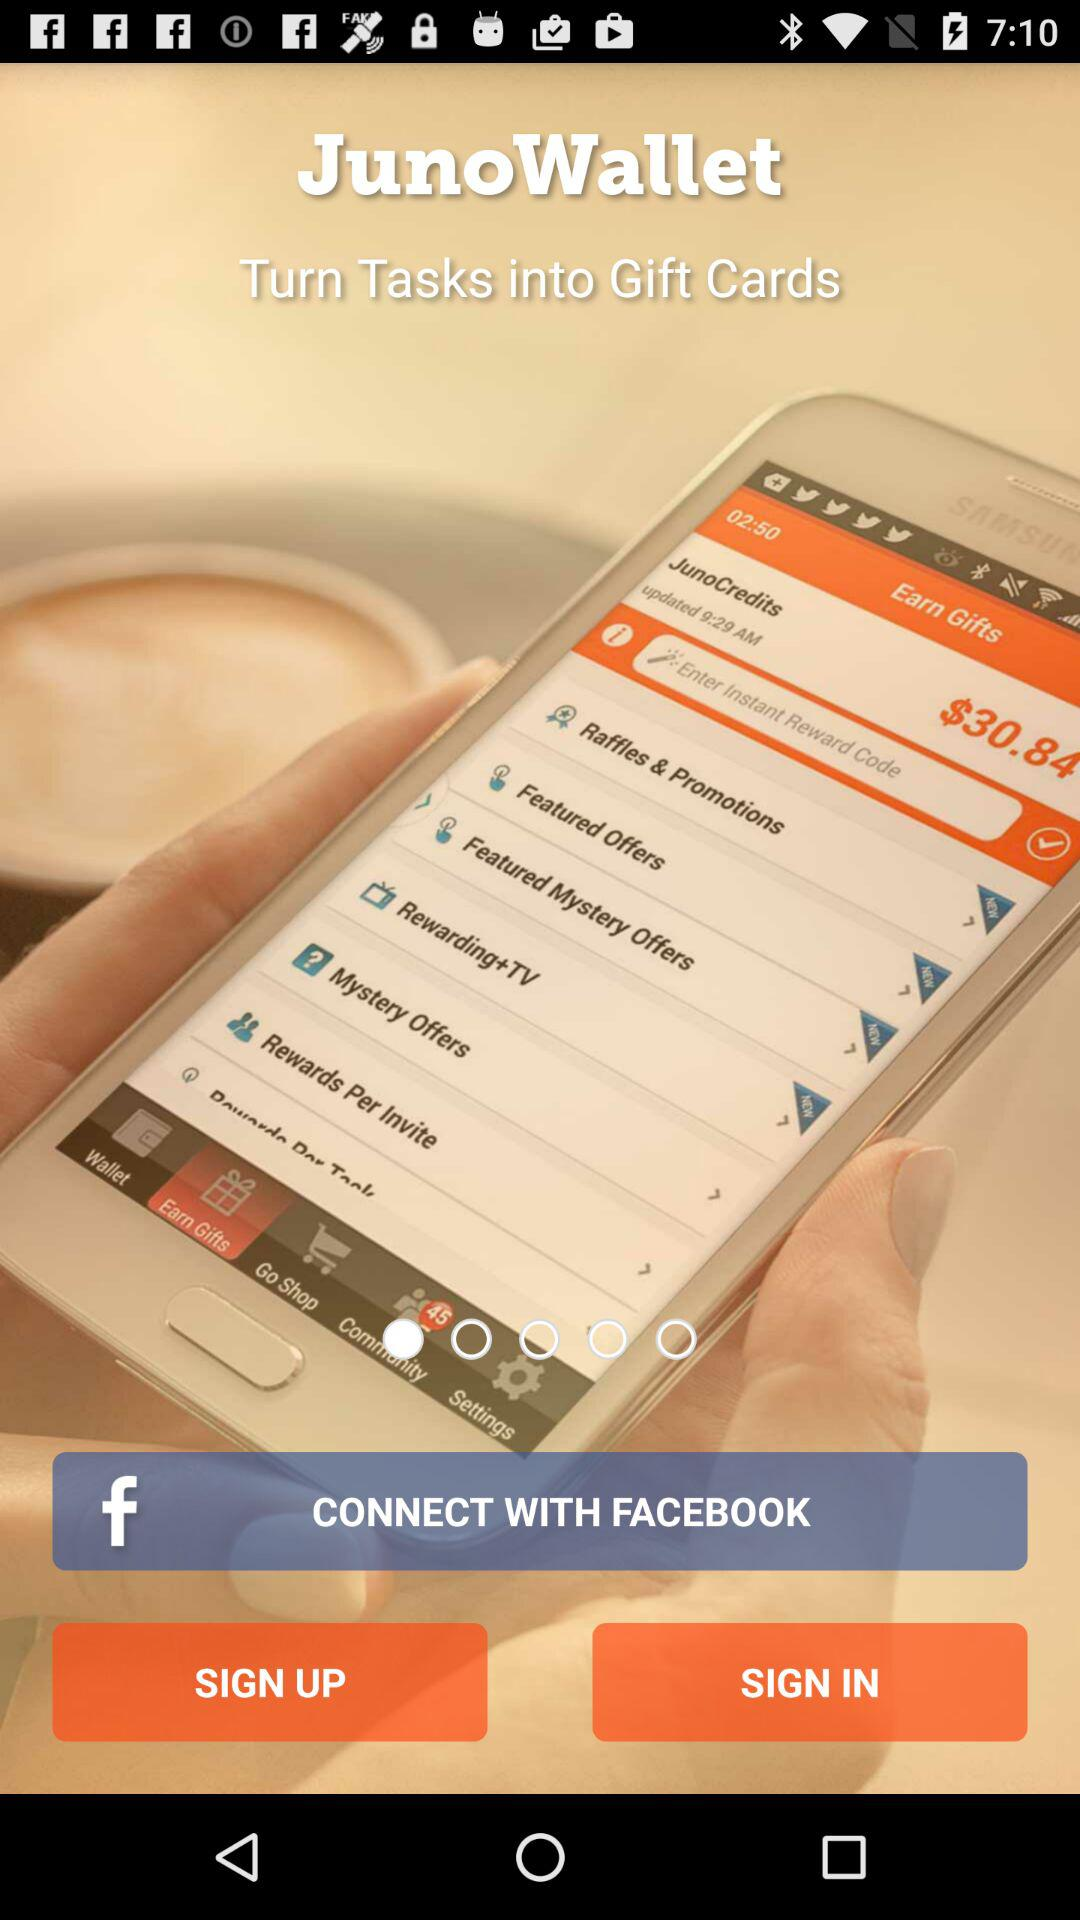What is the application name? The application name is "JunoWallet". 